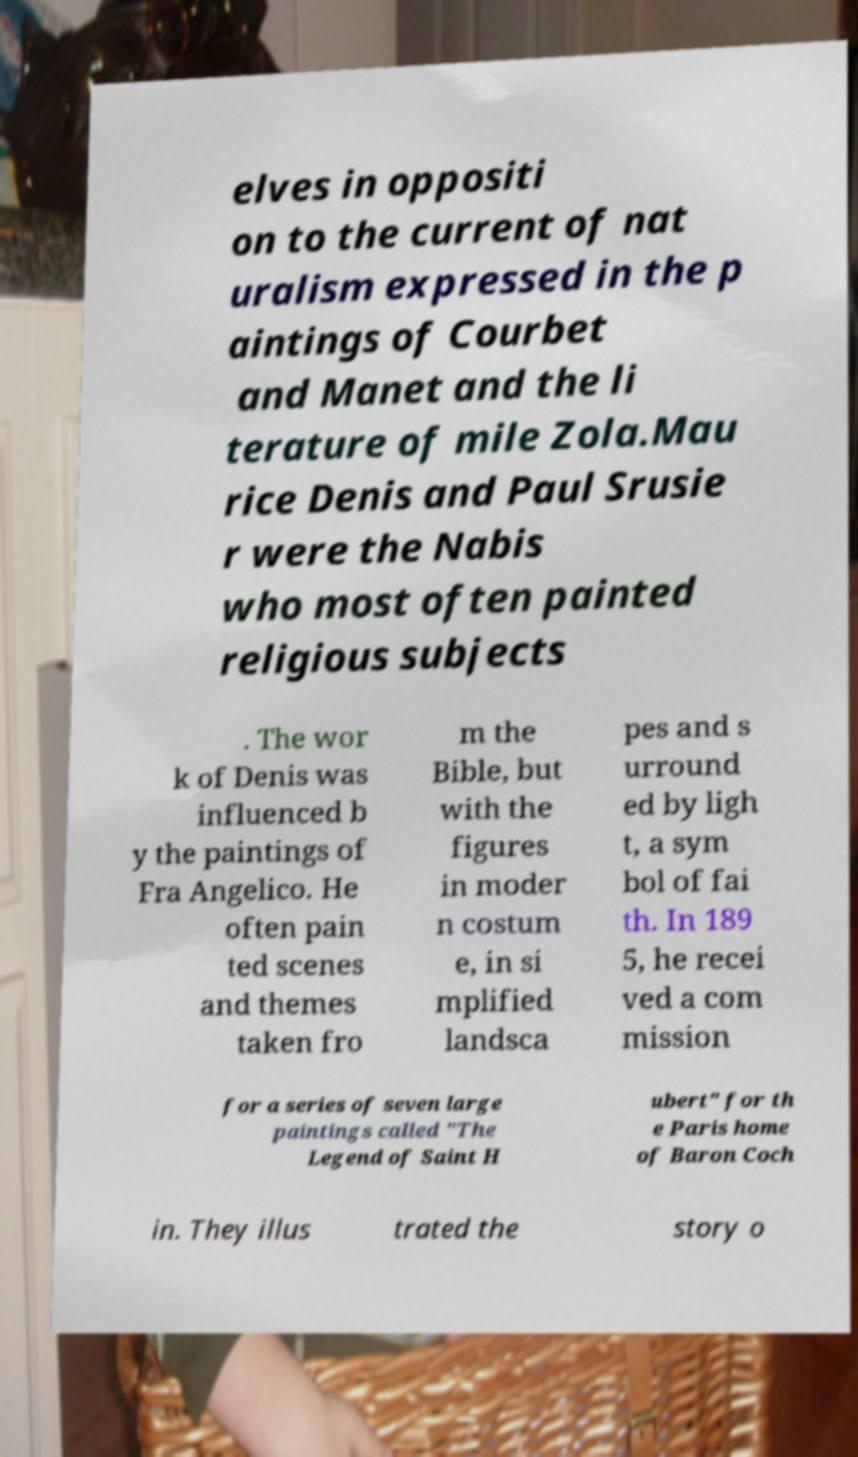I need the written content from this picture converted into text. Can you do that? elves in oppositi on to the current of nat uralism expressed in the p aintings of Courbet and Manet and the li terature of mile Zola.Mau rice Denis and Paul Srusie r were the Nabis who most often painted religious subjects . The wor k of Denis was influenced b y the paintings of Fra Angelico. He often pain ted scenes and themes taken fro m the Bible, but with the figures in moder n costum e, in si mplified landsca pes and s urround ed by ligh t, a sym bol of fai th. In 189 5, he recei ved a com mission for a series of seven large paintings called "The Legend of Saint H ubert" for th e Paris home of Baron Coch in. They illus trated the story o 